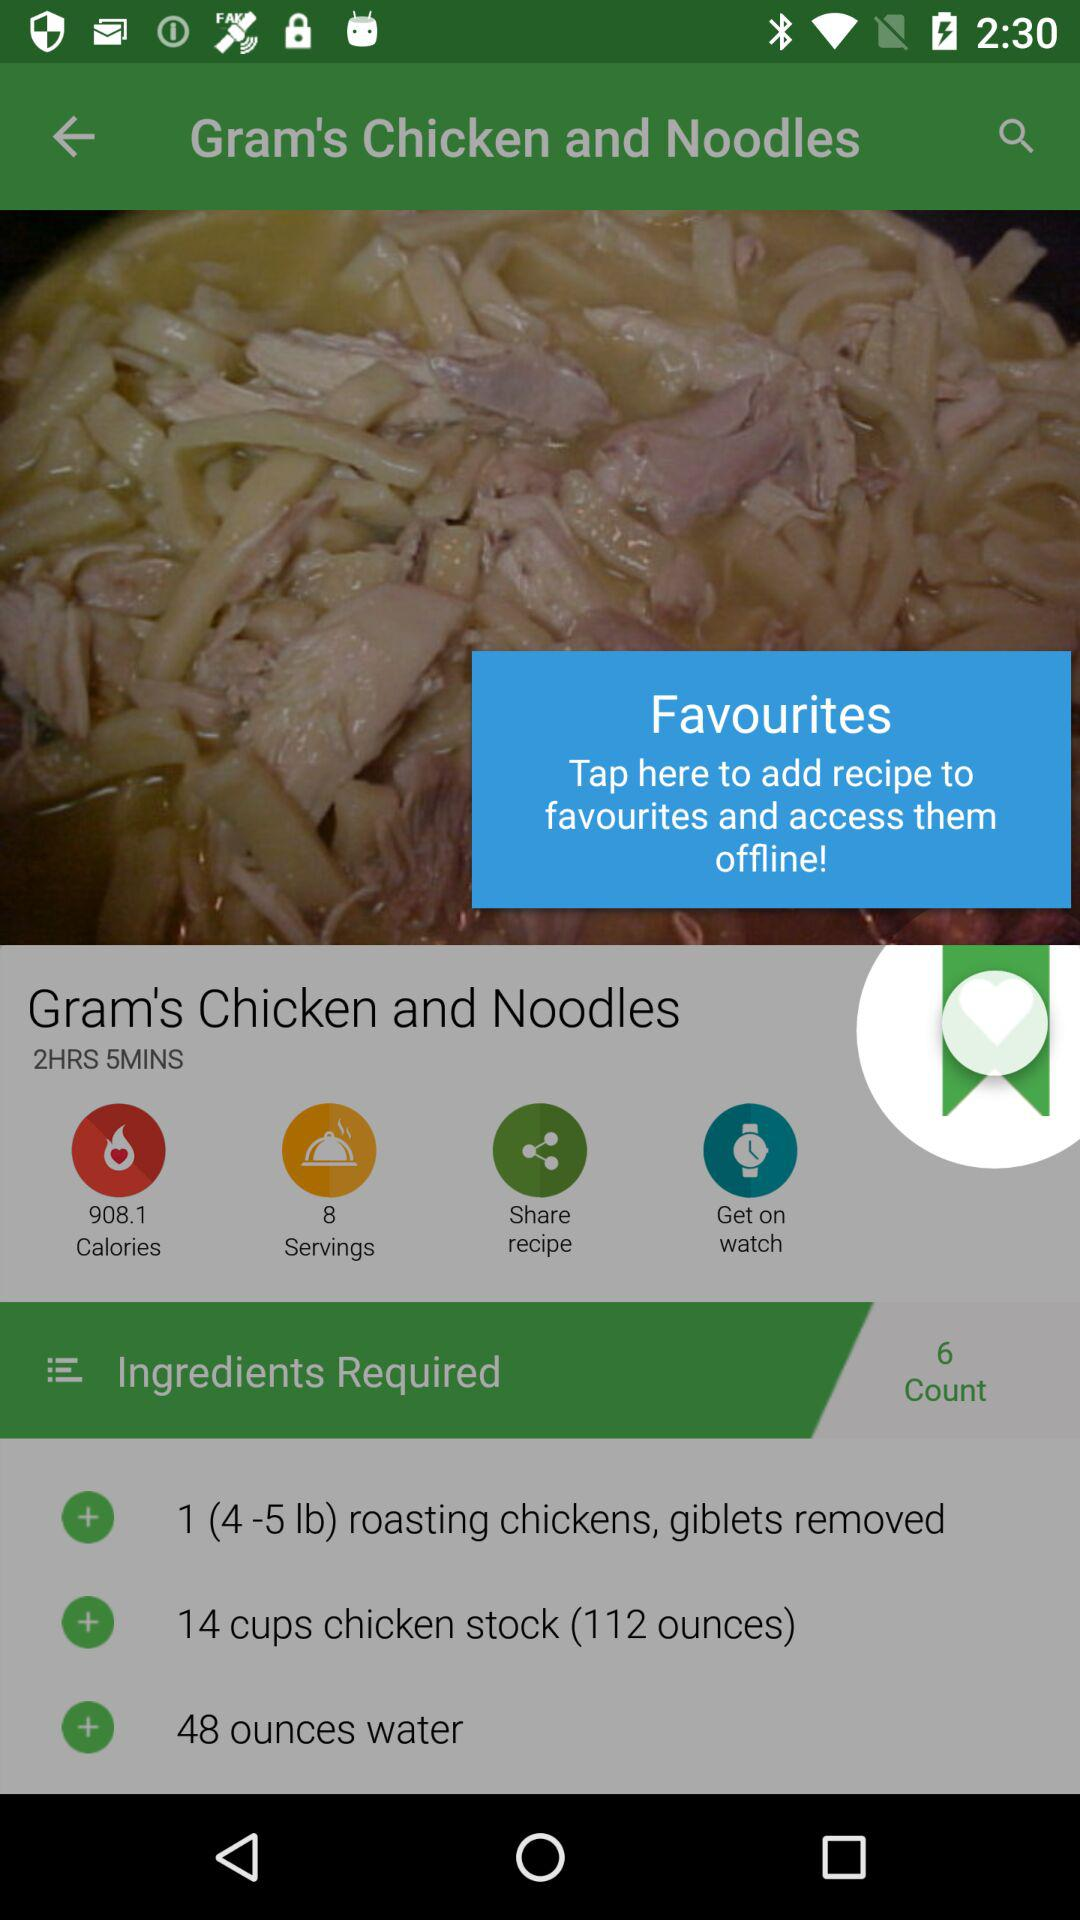What is the duration of cooking? The duration is 2 hours 5 minutes. 